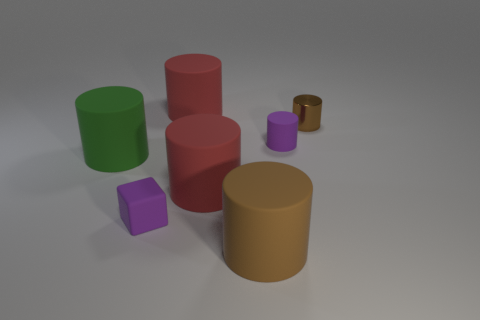Subtract all brown cylinders. How many cylinders are left? 4 Subtract all brown cylinders. How many cylinders are left? 4 Subtract 2 cylinders. How many cylinders are left? 4 Subtract all brown cylinders. Subtract all red cubes. How many cylinders are left? 4 Add 3 red metallic blocks. How many objects exist? 10 Subtract all cylinders. How many objects are left? 1 Add 5 big cylinders. How many big cylinders exist? 9 Subtract 0 gray cubes. How many objects are left? 7 Subtract all big cyan metallic cubes. Subtract all rubber objects. How many objects are left? 1 Add 4 tiny cylinders. How many tiny cylinders are left? 6 